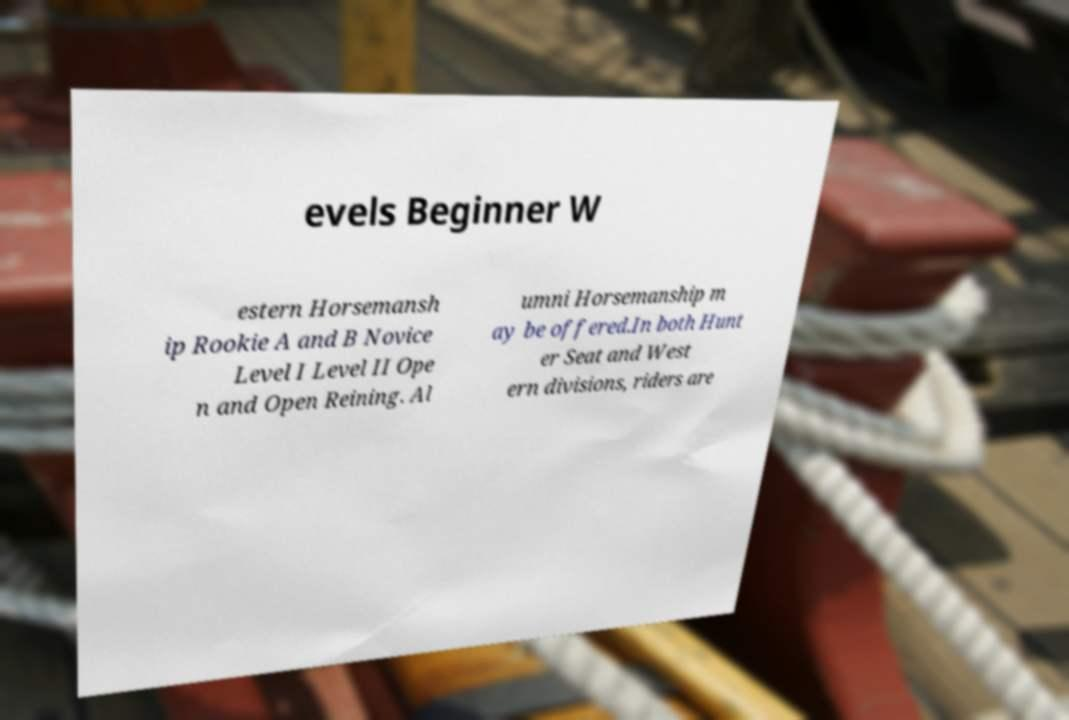Can you accurately transcribe the text from the provided image for me? evels Beginner W estern Horsemansh ip Rookie A and B Novice Level I Level II Ope n and Open Reining. Al umni Horsemanship m ay be offered.In both Hunt er Seat and West ern divisions, riders are 